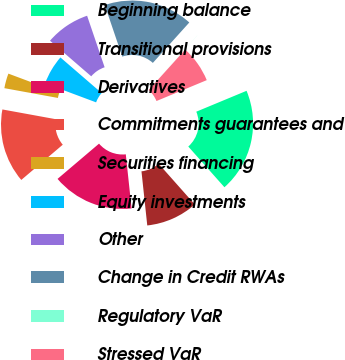<chart> <loc_0><loc_0><loc_500><loc_500><pie_chart><fcel>Beginning balance<fcel>Transitional provisions<fcel>Derivatives<fcel>Commitments guarantees and<fcel>Securities financing<fcel>Equity investments<fcel>Other<fcel>Change in Credit RWAs<fcel>Regulatory VaR<fcel>Stressed VaR<nl><fcel>19.71%<fcel>9.86%<fcel>15.49%<fcel>14.08%<fcel>2.82%<fcel>5.64%<fcel>8.45%<fcel>16.9%<fcel>0.01%<fcel>7.04%<nl></chart> 